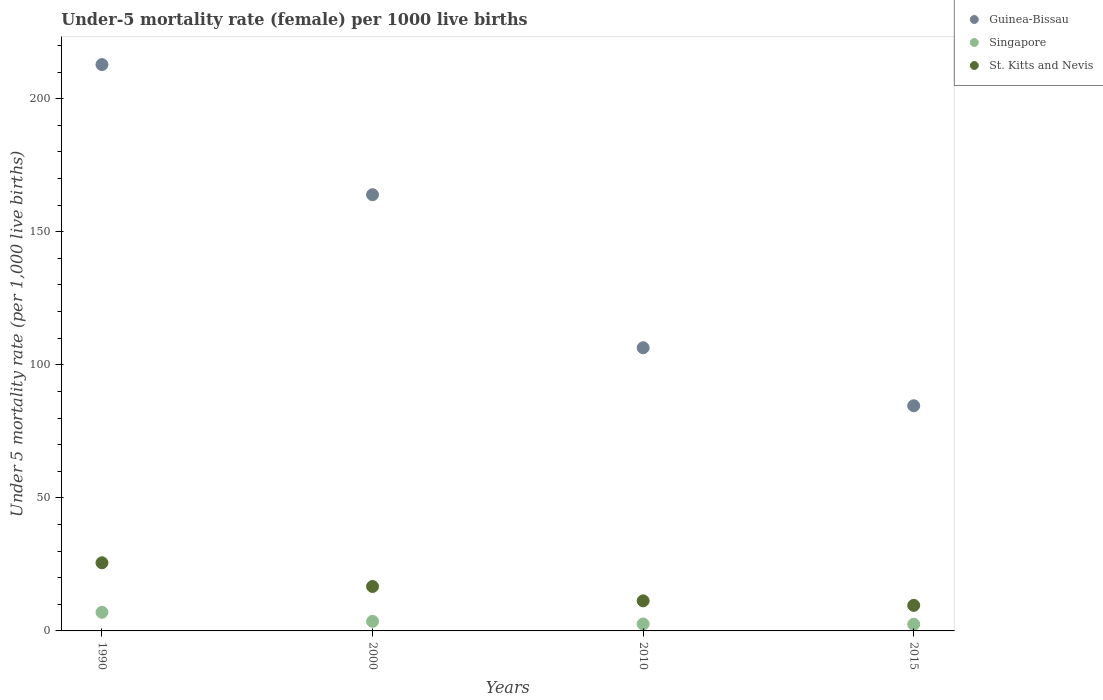Is the number of dotlines equal to the number of legend labels?
Provide a short and direct response. Yes. What is the under-five mortality rate in Guinea-Bissau in 1990?
Keep it short and to the point. 212.8. Across all years, what is the maximum under-five mortality rate in Guinea-Bissau?
Your answer should be very brief. 212.8. In which year was the under-five mortality rate in Guinea-Bissau maximum?
Offer a terse response. 1990. In which year was the under-five mortality rate in St. Kitts and Nevis minimum?
Your response must be concise. 2015. What is the total under-five mortality rate in Guinea-Bissau in the graph?
Provide a succinct answer. 567.7. What is the difference between the under-five mortality rate in St. Kitts and Nevis in 1990 and that in 2015?
Make the answer very short. 16. What is the difference between the under-five mortality rate in Guinea-Bissau in 2015 and the under-five mortality rate in St. Kitts and Nevis in 2010?
Give a very brief answer. 73.3. What is the average under-five mortality rate in Singapore per year?
Your response must be concise. 3.92. In the year 2010, what is the difference between the under-five mortality rate in Guinea-Bissau and under-five mortality rate in Singapore?
Ensure brevity in your answer.  103.8. In how many years, is the under-five mortality rate in Guinea-Bissau greater than 90?
Your answer should be compact. 3. What is the ratio of the under-five mortality rate in St. Kitts and Nevis in 1990 to that in 2000?
Offer a terse response. 1.53. Is the difference between the under-five mortality rate in Guinea-Bissau in 2000 and 2010 greater than the difference between the under-five mortality rate in Singapore in 2000 and 2010?
Provide a short and direct response. Yes. What is the difference between the highest and the second highest under-five mortality rate in Guinea-Bissau?
Make the answer very short. 48.9. What is the difference between the highest and the lowest under-five mortality rate in Guinea-Bissau?
Provide a short and direct response. 128.2. Is the sum of the under-five mortality rate in St. Kitts and Nevis in 1990 and 2000 greater than the maximum under-five mortality rate in Guinea-Bissau across all years?
Ensure brevity in your answer.  No. Does the under-five mortality rate in St. Kitts and Nevis monotonically increase over the years?
Offer a very short reply. No. Is the under-five mortality rate in Guinea-Bissau strictly greater than the under-five mortality rate in Singapore over the years?
Your answer should be very brief. Yes. Are the values on the major ticks of Y-axis written in scientific E-notation?
Your answer should be compact. No. Does the graph contain grids?
Offer a terse response. No. Where does the legend appear in the graph?
Give a very brief answer. Top right. How are the legend labels stacked?
Your answer should be compact. Vertical. What is the title of the graph?
Provide a succinct answer. Under-5 mortality rate (female) per 1000 live births. Does "Tonga" appear as one of the legend labels in the graph?
Give a very brief answer. No. What is the label or title of the Y-axis?
Offer a terse response. Under 5 mortality rate (per 1,0 live births). What is the Under 5 mortality rate (per 1,000 live births) of Guinea-Bissau in 1990?
Your answer should be very brief. 212.8. What is the Under 5 mortality rate (per 1,000 live births) of Singapore in 1990?
Keep it short and to the point. 7. What is the Under 5 mortality rate (per 1,000 live births) in St. Kitts and Nevis in 1990?
Your answer should be compact. 25.6. What is the Under 5 mortality rate (per 1,000 live births) of Guinea-Bissau in 2000?
Provide a succinct answer. 163.9. What is the Under 5 mortality rate (per 1,000 live births) of Singapore in 2000?
Keep it short and to the point. 3.6. What is the Under 5 mortality rate (per 1,000 live births) in Guinea-Bissau in 2010?
Keep it short and to the point. 106.4. What is the Under 5 mortality rate (per 1,000 live births) in Guinea-Bissau in 2015?
Your answer should be compact. 84.6. What is the Under 5 mortality rate (per 1,000 live births) in Singapore in 2015?
Your answer should be very brief. 2.5. What is the Under 5 mortality rate (per 1,000 live births) in St. Kitts and Nevis in 2015?
Provide a succinct answer. 9.6. Across all years, what is the maximum Under 5 mortality rate (per 1,000 live births) of Guinea-Bissau?
Your response must be concise. 212.8. Across all years, what is the maximum Under 5 mortality rate (per 1,000 live births) in Singapore?
Provide a succinct answer. 7. Across all years, what is the maximum Under 5 mortality rate (per 1,000 live births) of St. Kitts and Nevis?
Your response must be concise. 25.6. Across all years, what is the minimum Under 5 mortality rate (per 1,000 live births) in Guinea-Bissau?
Your response must be concise. 84.6. Across all years, what is the minimum Under 5 mortality rate (per 1,000 live births) of St. Kitts and Nevis?
Your response must be concise. 9.6. What is the total Under 5 mortality rate (per 1,000 live births) in Guinea-Bissau in the graph?
Provide a succinct answer. 567.7. What is the total Under 5 mortality rate (per 1,000 live births) of St. Kitts and Nevis in the graph?
Offer a very short reply. 63.2. What is the difference between the Under 5 mortality rate (per 1,000 live births) in Guinea-Bissau in 1990 and that in 2000?
Offer a very short reply. 48.9. What is the difference between the Under 5 mortality rate (per 1,000 live births) in Singapore in 1990 and that in 2000?
Offer a terse response. 3.4. What is the difference between the Under 5 mortality rate (per 1,000 live births) of Guinea-Bissau in 1990 and that in 2010?
Your answer should be compact. 106.4. What is the difference between the Under 5 mortality rate (per 1,000 live births) in Guinea-Bissau in 1990 and that in 2015?
Your response must be concise. 128.2. What is the difference between the Under 5 mortality rate (per 1,000 live births) of Guinea-Bissau in 2000 and that in 2010?
Ensure brevity in your answer.  57.5. What is the difference between the Under 5 mortality rate (per 1,000 live births) of Singapore in 2000 and that in 2010?
Ensure brevity in your answer.  1. What is the difference between the Under 5 mortality rate (per 1,000 live births) in Guinea-Bissau in 2000 and that in 2015?
Provide a succinct answer. 79.3. What is the difference between the Under 5 mortality rate (per 1,000 live births) of Guinea-Bissau in 2010 and that in 2015?
Provide a short and direct response. 21.8. What is the difference between the Under 5 mortality rate (per 1,000 live births) in St. Kitts and Nevis in 2010 and that in 2015?
Keep it short and to the point. 1.7. What is the difference between the Under 5 mortality rate (per 1,000 live births) in Guinea-Bissau in 1990 and the Under 5 mortality rate (per 1,000 live births) in Singapore in 2000?
Your answer should be very brief. 209.2. What is the difference between the Under 5 mortality rate (per 1,000 live births) in Guinea-Bissau in 1990 and the Under 5 mortality rate (per 1,000 live births) in St. Kitts and Nevis in 2000?
Provide a short and direct response. 196.1. What is the difference between the Under 5 mortality rate (per 1,000 live births) of Guinea-Bissau in 1990 and the Under 5 mortality rate (per 1,000 live births) of Singapore in 2010?
Provide a short and direct response. 210.2. What is the difference between the Under 5 mortality rate (per 1,000 live births) in Guinea-Bissau in 1990 and the Under 5 mortality rate (per 1,000 live births) in St. Kitts and Nevis in 2010?
Offer a very short reply. 201.5. What is the difference between the Under 5 mortality rate (per 1,000 live births) in Singapore in 1990 and the Under 5 mortality rate (per 1,000 live births) in St. Kitts and Nevis in 2010?
Offer a very short reply. -4.3. What is the difference between the Under 5 mortality rate (per 1,000 live births) in Guinea-Bissau in 1990 and the Under 5 mortality rate (per 1,000 live births) in Singapore in 2015?
Provide a succinct answer. 210.3. What is the difference between the Under 5 mortality rate (per 1,000 live births) in Guinea-Bissau in 1990 and the Under 5 mortality rate (per 1,000 live births) in St. Kitts and Nevis in 2015?
Your response must be concise. 203.2. What is the difference between the Under 5 mortality rate (per 1,000 live births) in Guinea-Bissau in 2000 and the Under 5 mortality rate (per 1,000 live births) in Singapore in 2010?
Make the answer very short. 161.3. What is the difference between the Under 5 mortality rate (per 1,000 live births) in Guinea-Bissau in 2000 and the Under 5 mortality rate (per 1,000 live births) in St. Kitts and Nevis in 2010?
Provide a short and direct response. 152.6. What is the difference between the Under 5 mortality rate (per 1,000 live births) in Singapore in 2000 and the Under 5 mortality rate (per 1,000 live births) in St. Kitts and Nevis in 2010?
Offer a terse response. -7.7. What is the difference between the Under 5 mortality rate (per 1,000 live births) in Guinea-Bissau in 2000 and the Under 5 mortality rate (per 1,000 live births) in Singapore in 2015?
Your answer should be very brief. 161.4. What is the difference between the Under 5 mortality rate (per 1,000 live births) of Guinea-Bissau in 2000 and the Under 5 mortality rate (per 1,000 live births) of St. Kitts and Nevis in 2015?
Your answer should be compact. 154.3. What is the difference between the Under 5 mortality rate (per 1,000 live births) of Singapore in 2000 and the Under 5 mortality rate (per 1,000 live births) of St. Kitts and Nevis in 2015?
Offer a terse response. -6. What is the difference between the Under 5 mortality rate (per 1,000 live births) of Guinea-Bissau in 2010 and the Under 5 mortality rate (per 1,000 live births) of Singapore in 2015?
Make the answer very short. 103.9. What is the difference between the Under 5 mortality rate (per 1,000 live births) in Guinea-Bissau in 2010 and the Under 5 mortality rate (per 1,000 live births) in St. Kitts and Nevis in 2015?
Your answer should be very brief. 96.8. What is the average Under 5 mortality rate (per 1,000 live births) in Guinea-Bissau per year?
Ensure brevity in your answer.  141.93. What is the average Under 5 mortality rate (per 1,000 live births) of Singapore per year?
Your response must be concise. 3.92. In the year 1990, what is the difference between the Under 5 mortality rate (per 1,000 live births) of Guinea-Bissau and Under 5 mortality rate (per 1,000 live births) of Singapore?
Your answer should be compact. 205.8. In the year 1990, what is the difference between the Under 5 mortality rate (per 1,000 live births) in Guinea-Bissau and Under 5 mortality rate (per 1,000 live births) in St. Kitts and Nevis?
Offer a terse response. 187.2. In the year 1990, what is the difference between the Under 5 mortality rate (per 1,000 live births) of Singapore and Under 5 mortality rate (per 1,000 live births) of St. Kitts and Nevis?
Your answer should be compact. -18.6. In the year 2000, what is the difference between the Under 5 mortality rate (per 1,000 live births) of Guinea-Bissau and Under 5 mortality rate (per 1,000 live births) of Singapore?
Ensure brevity in your answer.  160.3. In the year 2000, what is the difference between the Under 5 mortality rate (per 1,000 live births) in Guinea-Bissau and Under 5 mortality rate (per 1,000 live births) in St. Kitts and Nevis?
Provide a succinct answer. 147.2. In the year 2010, what is the difference between the Under 5 mortality rate (per 1,000 live births) of Guinea-Bissau and Under 5 mortality rate (per 1,000 live births) of Singapore?
Make the answer very short. 103.8. In the year 2010, what is the difference between the Under 5 mortality rate (per 1,000 live births) in Guinea-Bissau and Under 5 mortality rate (per 1,000 live births) in St. Kitts and Nevis?
Offer a very short reply. 95.1. In the year 2010, what is the difference between the Under 5 mortality rate (per 1,000 live births) of Singapore and Under 5 mortality rate (per 1,000 live births) of St. Kitts and Nevis?
Ensure brevity in your answer.  -8.7. In the year 2015, what is the difference between the Under 5 mortality rate (per 1,000 live births) of Guinea-Bissau and Under 5 mortality rate (per 1,000 live births) of Singapore?
Keep it short and to the point. 82.1. In the year 2015, what is the difference between the Under 5 mortality rate (per 1,000 live births) of Guinea-Bissau and Under 5 mortality rate (per 1,000 live births) of St. Kitts and Nevis?
Provide a short and direct response. 75. In the year 2015, what is the difference between the Under 5 mortality rate (per 1,000 live births) of Singapore and Under 5 mortality rate (per 1,000 live births) of St. Kitts and Nevis?
Provide a short and direct response. -7.1. What is the ratio of the Under 5 mortality rate (per 1,000 live births) of Guinea-Bissau in 1990 to that in 2000?
Make the answer very short. 1.3. What is the ratio of the Under 5 mortality rate (per 1,000 live births) in Singapore in 1990 to that in 2000?
Give a very brief answer. 1.94. What is the ratio of the Under 5 mortality rate (per 1,000 live births) in St. Kitts and Nevis in 1990 to that in 2000?
Your response must be concise. 1.53. What is the ratio of the Under 5 mortality rate (per 1,000 live births) of Guinea-Bissau in 1990 to that in 2010?
Your answer should be very brief. 2. What is the ratio of the Under 5 mortality rate (per 1,000 live births) in Singapore in 1990 to that in 2010?
Provide a succinct answer. 2.69. What is the ratio of the Under 5 mortality rate (per 1,000 live births) of St. Kitts and Nevis in 1990 to that in 2010?
Ensure brevity in your answer.  2.27. What is the ratio of the Under 5 mortality rate (per 1,000 live births) of Guinea-Bissau in 1990 to that in 2015?
Provide a short and direct response. 2.52. What is the ratio of the Under 5 mortality rate (per 1,000 live births) in St. Kitts and Nevis in 1990 to that in 2015?
Offer a very short reply. 2.67. What is the ratio of the Under 5 mortality rate (per 1,000 live births) of Guinea-Bissau in 2000 to that in 2010?
Offer a terse response. 1.54. What is the ratio of the Under 5 mortality rate (per 1,000 live births) in Singapore in 2000 to that in 2010?
Keep it short and to the point. 1.38. What is the ratio of the Under 5 mortality rate (per 1,000 live births) in St. Kitts and Nevis in 2000 to that in 2010?
Offer a very short reply. 1.48. What is the ratio of the Under 5 mortality rate (per 1,000 live births) in Guinea-Bissau in 2000 to that in 2015?
Provide a succinct answer. 1.94. What is the ratio of the Under 5 mortality rate (per 1,000 live births) in Singapore in 2000 to that in 2015?
Ensure brevity in your answer.  1.44. What is the ratio of the Under 5 mortality rate (per 1,000 live births) of St. Kitts and Nevis in 2000 to that in 2015?
Offer a very short reply. 1.74. What is the ratio of the Under 5 mortality rate (per 1,000 live births) in Guinea-Bissau in 2010 to that in 2015?
Your answer should be compact. 1.26. What is the ratio of the Under 5 mortality rate (per 1,000 live births) in Singapore in 2010 to that in 2015?
Provide a succinct answer. 1.04. What is the ratio of the Under 5 mortality rate (per 1,000 live births) of St. Kitts and Nevis in 2010 to that in 2015?
Your response must be concise. 1.18. What is the difference between the highest and the second highest Under 5 mortality rate (per 1,000 live births) of Guinea-Bissau?
Your answer should be compact. 48.9. What is the difference between the highest and the second highest Under 5 mortality rate (per 1,000 live births) of Singapore?
Your answer should be very brief. 3.4. What is the difference between the highest and the lowest Under 5 mortality rate (per 1,000 live births) in Guinea-Bissau?
Provide a short and direct response. 128.2. What is the difference between the highest and the lowest Under 5 mortality rate (per 1,000 live births) of St. Kitts and Nevis?
Provide a short and direct response. 16. 